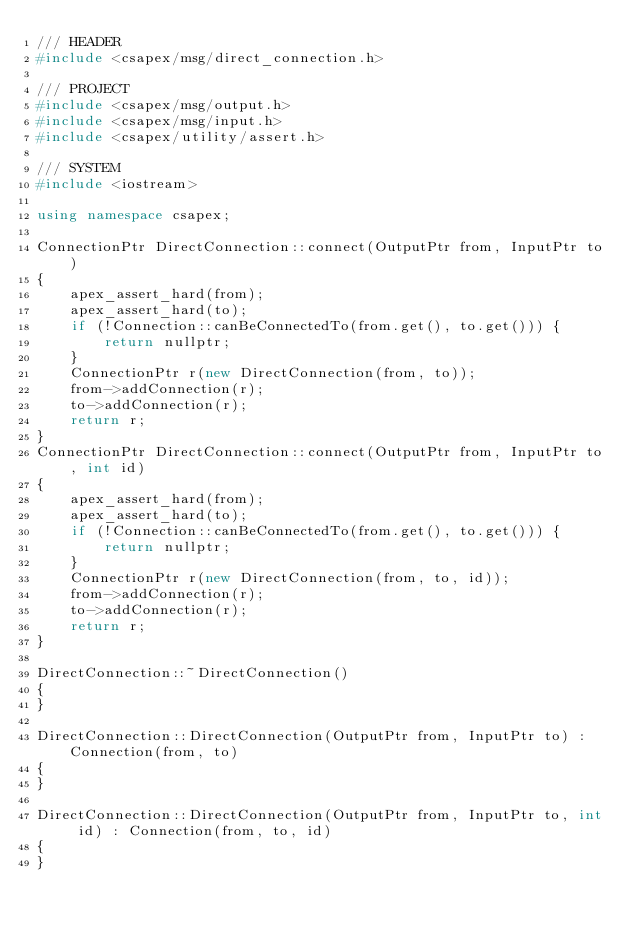Convert code to text. <code><loc_0><loc_0><loc_500><loc_500><_C++_>/// HEADER
#include <csapex/msg/direct_connection.h>

/// PROJECT
#include <csapex/msg/output.h>
#include <csapex/msg/input.h>
#include <csapex/utility/assert.h>

/// SYSTEM
#include <iostream>

using namespace csapex;

ConnectionPtr DirectConnection::connect(OutputPtr from, InputPtr to)
{
    apex_assert_hard(from);
    apex_assert_hard(to);
    if (!Connection::canBeConnectedTo(from.get(), to.get())) {
        return nullptr;
    }
    ConnectionPtr r(new DirectConnection(from, to));
    from->addConnection(r);
    to->addConnection(r);
    return r;
}
ConnectionPtr DirectConnection::connect(OutputPtr from, InputPtr to, int id)
{
    apex_assert_hard(from);
    apex_assert_hard(to);
    if (!Connection::canBeConnectedTo(from.get(), to.get())) {
        return nullptr;
    }
    ConnectionPtr r(new DirectConnection(from, to, id));
    from->addConnection(r);
    to->addConnection(r);
    return r;
}

DirectConnection::~DirectConnection()
{
}

DirectConnection::DirectConnection(OutputPtr from, InputPtr to) : Connection(from, to)
{
}

DirectConnection::DirectConnection(OutputPtr from, InputPtr to, int id) : Connection(from, to, id)
{
}
</code> 